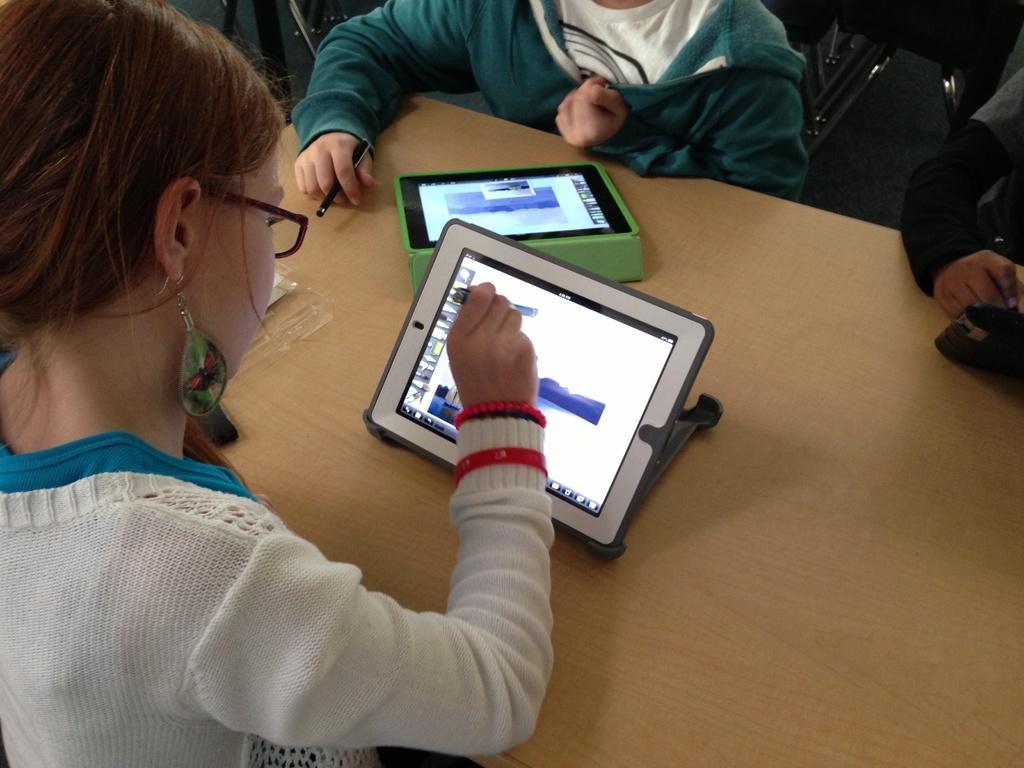Describe this image in one or two sentences. In the picture I can see kids sitting around table on which there are some electronic gadgets. 